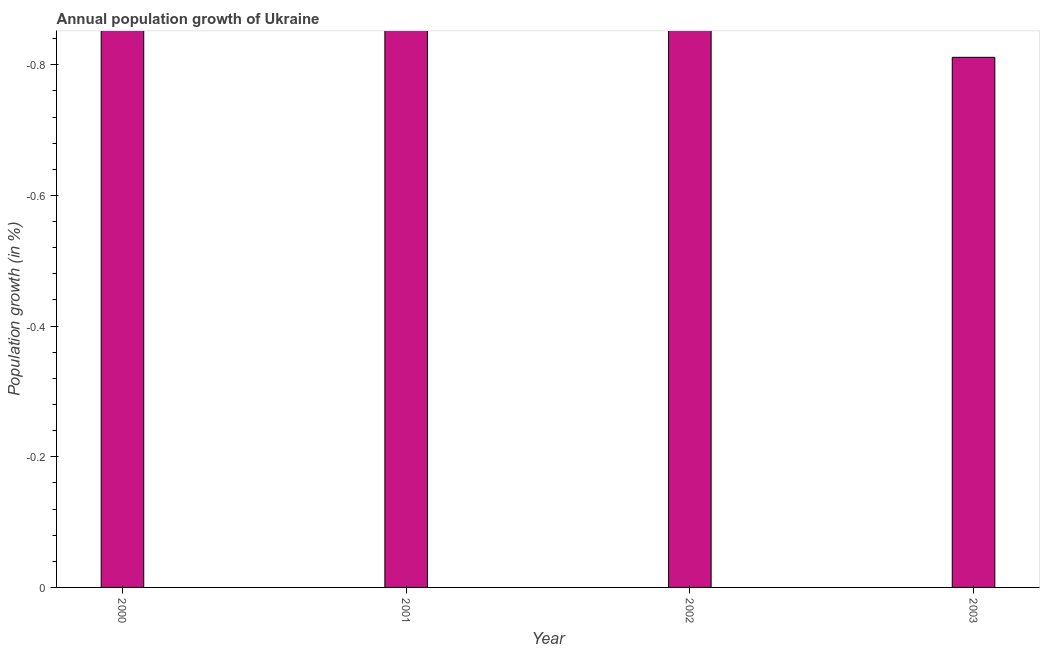Does the graph contain any zero values?
Offer a very short reply. Yes. Does the graph contain grids?
Your answer should be compact. No. What is the title of the graph?
Provide a short and direct response. Annual population growth of Ukraine. What is the label or title of the X-axis?
Make the answer very short. Year. What is the label or title of the Y-axis?
Give a very brief answer. Population growth (in %). What is the population growth in 2000?
Give a very brief answer. 0. In how many years, is the population growth greater than -0.48 %?
Give a very brief answer. 0. Are all the bars in the graph horizontal?
Give a very brief answer. No. How many years are there in the graph?
Make the answer very short. 4. What is the difference between two consecutive major ticks on the Y-axis?
Offer a very short reply. 0.2. Are the values on the major ticks of Y-axis written in scientific E-notation?
Your answer should be compact. No. What is the Population growth (in %) in 2000?
Make the answer very short. 0. 